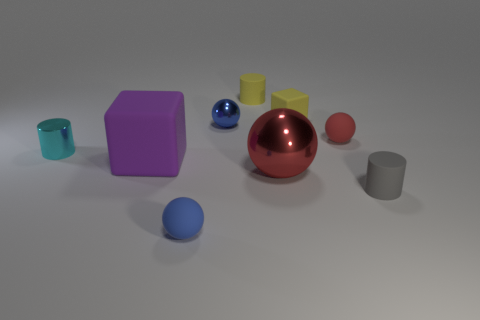There is a matte sphere in front of the large metallic thing; how big is it?
Provide a succinct answer. Small. Are there fewer small gray cylinders than matte cubes?
Your answer should be compact. Yes. Are there any rubber balls that have the same color as the small metal cylinder?
Give a very brief answer. No. What shape is the shiny object that is both on the left side of the small yellow rubber cylinder and to the right of the cyan metal thing?
Make the answer very short. Sphere. There is a big object to the left of the rubber sphere in front of the cyan metallic cylinder; what is its shape?
Your answer should be compact. Cube. Do the gray rubber thing and the small blue shiny thing have the same shape?
Your response must be concise. No. What is the material of the other object that is the same color as the big metal thing?
Provide a succinct answer. Rubber. Is the tiny metal ball the same color as the small block?
Ensure brevity in your answer.  No. How many big red spheres are in front of the matte cylinder in front of the block behind the red matte thing?
Make the answer very short. 0. There is a gray thing that is the same material as the big block; what shape is it?
Ensure brevity in your answer.  Cylinder. 